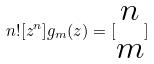Convert formula to latex. <formula><loc_0><loc_0><loc_500><loc_500>n ! [ z ^ { n } ] g _ { m } ( z ) = [ \begin{matrix} n \\ m \end{matrix} ]</formula> 